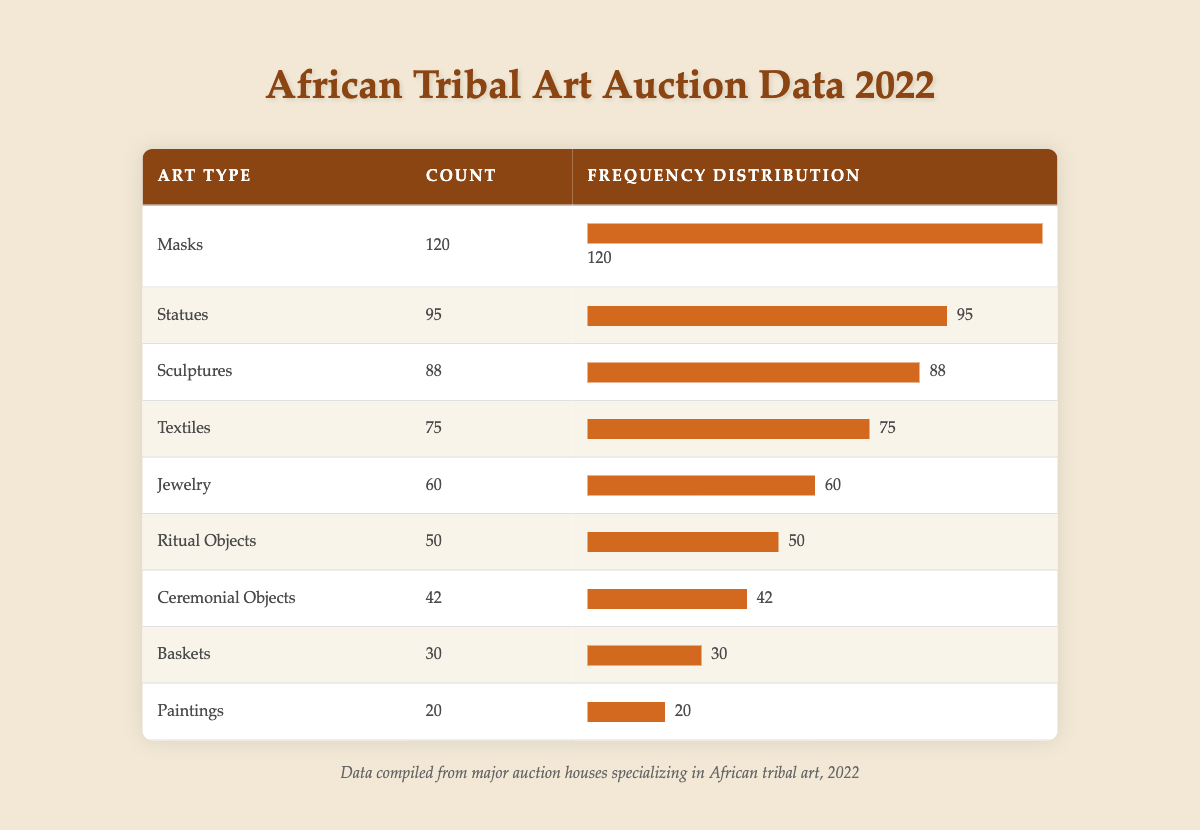What type of African tribal art had the highest count sold in auctions in 2022? By examining the table, we can see that "Masks" had the highest count of 120. It is the first entry in the table, making it straightforward to identify.
Answer: Masks How many more statues were sold compared to paintings in 2022? To find the difference, we subtract the count of paintings (20) from the count of statues (95): 95 - 20 = 75. Therefore, 75 more statues were sold than paintings.
Answer: 75 Is the count of jewelry sold greater than that of ritual objects? Looking at the counts, jewelry had 60 sold, while ritual objects had 50. Since 60 is greater than 50, the statement is true.
Answer: Yes What was the total count of textiles and sculptures sold in 2022? The count of textiles is 75 and the count of sculptures is 88. We add these two counts together to get the total: 75 + 88 = 163.
Answer: 163 Which types of African tribal art had a count of less than 50 sold in auctions? Reviewing the table, we can see that "Ritual Objects" (50), "Ceremonial Objects" (42), "Baskets" (30), and "Paintings" (20) all had counts below 50, but only "Ceremonial Objects," "Baskets," and "Paintings" had counts strictly less than 50.
Answer: Ceremonial Objects, Baskets, Paintings What was the average count of the art types listed in the table? To calculate the average, we first need to sum all counts: (120 + 95 + 88 + 75 + 60 + 50 + 42 + 30 + 20) = 600. There are 9 art types, so we divide the total by 9 to find the average: 600 / 9 = 66.67.
Answer: 66.67 How many types of art had a count of 70 or more sold? From the table, we see that the counts for Masks (120), Statues (95), Sculptures (88), and Textiles (75) are all 70 or more. Thus, there are 4 types of art that meet this criterion.
Answer: 4 Was the count of baskets sold greater than that of ceremonial objects? The count for baskets is 30, while for ceremonial objects, it is 42. Since 30 is less than 42, the statement is false.
Answer: No 